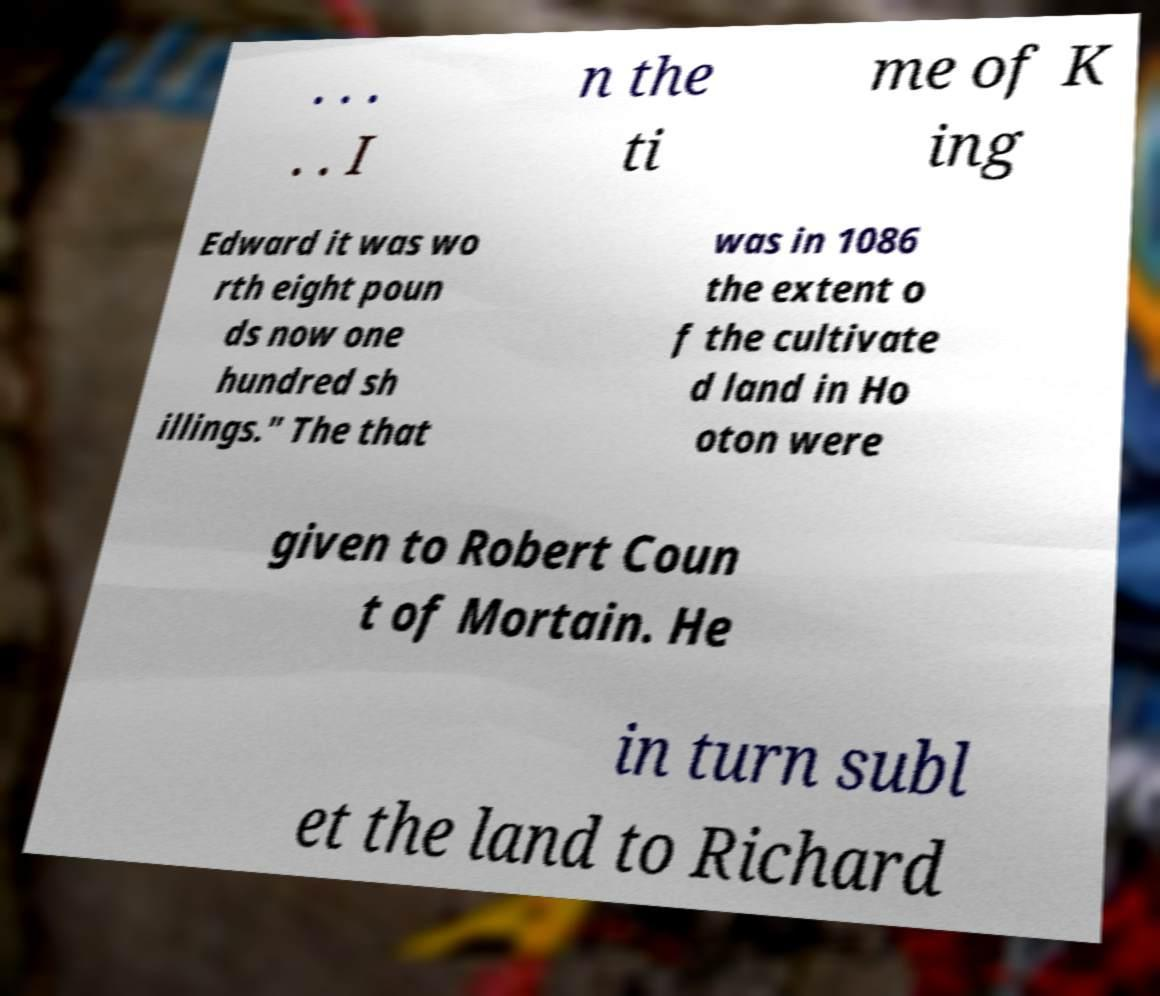There's text embedded in this image that I need extracted. Can you transcribe it verbatim? . . . . . I n the ti me of K ing Edward it was wo rth eight poun ds now one hundred sh illings." The that was in 1086 the extent o f the cultivate d land in Ho oton were given to Robert Coun t of Mortain. He in turn subl et the land to Richard 